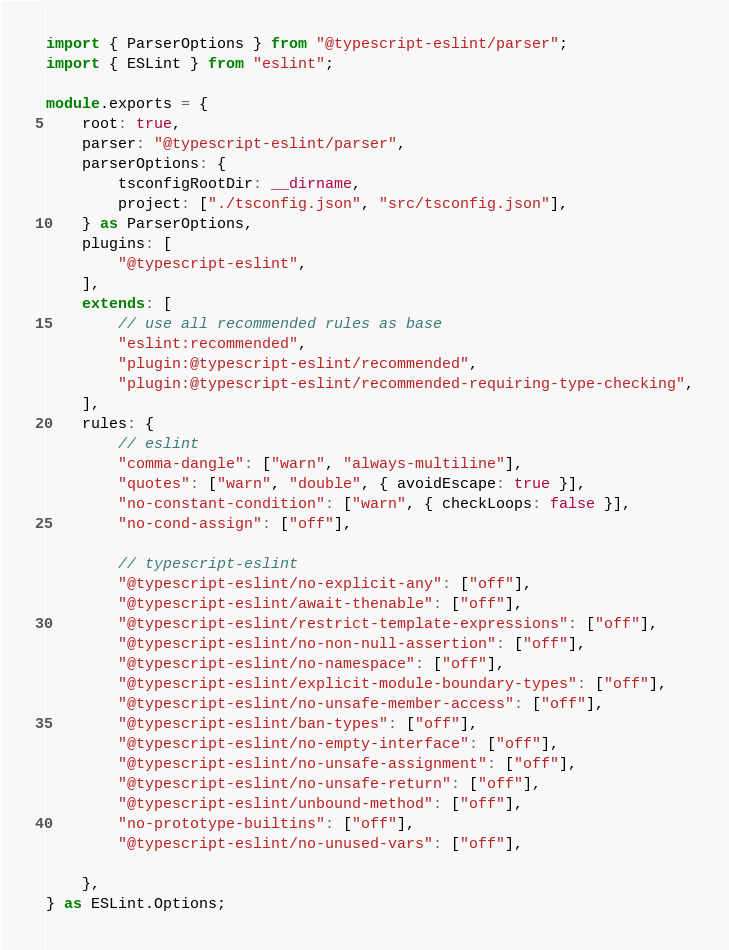<code> <loc_0><loc_0><loc_500><loc_500><_TypeScript_>import { ParserOptions } from "@typescript-eslint/parser";
import { ESLint } from "eslint";

module.exports = {
	root: true,
	parser: "@typescript-eslint/parser",
	parserOptions: {
		tsconfigRootDir: __dirname,
		project: ["./tsconfig.json", "src/tsconfig.json"],
	} as ParserOptions,
	plugins: [
		"@typescript-eslint",
	],
	extends: [
		// use all recommended rules as base
		"eslint:recommended",
		"plugin:@typescript-eslint/recommended",
		"plugin:@typescript-eslint/recommended-requiring-type-checking",
	],
	rules: {
		// eslint
		"comma-dangle": ["warn", "always-multiline"],
		"quotes": ["warn", "double", { avoidEscape: true }],
		"no-constant-condition": ["warn", { checkLoops: false }],
		"no-cond-assign": ["off"],

		// typescript-eslint
		"@typescript-eslint/no-explicit-any": ["off"],
		"@typescript-eslint/await-thenable": ["off"],
		"@typescript-eslint/restrict-template-expressions": ["off"],
		"@typescript-eslint/no-non-null-assertion": ["off"],
		"@typescript-eslint/no-namespace": ["off"],
		"@typescript-eslint/explicit-module-boundary-types": ["off"],
		"@typescript-eslint/no-unsafe-member-access": ["off"],
		"@typescript-eslint/ban-types": ["off"],
		"@typescript-eslint/no-empty-interface": ["off"],
		"@typescript-eslint/no-unsafe-assignment": ["off"],
		"@typescript-eslint/no-unsafe-return": ["off"],
		"@typescript-eslint/unbound-method": ["off"],
		"no-prototype-builtins": ["off"],
		"@typescript-eslint/no-unused-vars": ["off"],

	},
} as ESLint.Options;
</code> 